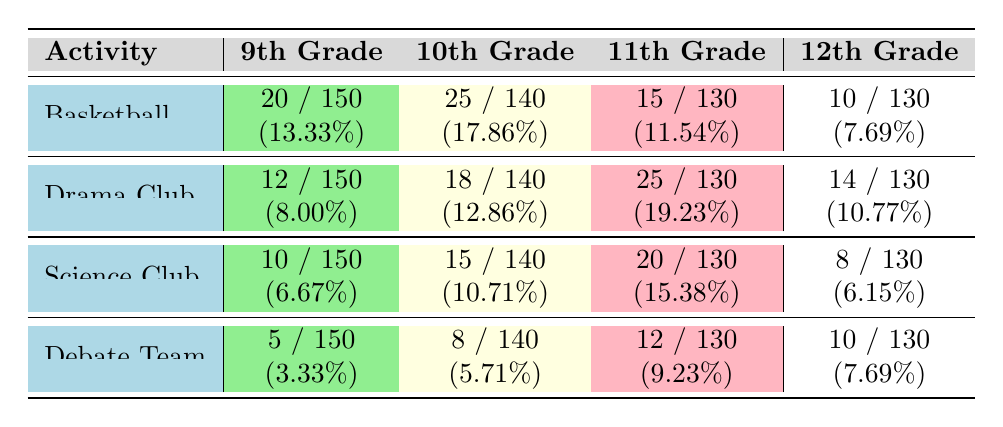What is the participation percentage for 10th Grade in the Basketball activity? The table shows that for the Basketball activity in 10th Grade, the participation percentage is listed as (17.86%).
Answer: 17.86% How many students in 11th Grade participated in the Drama Club? From the table, under the Drama Club, the entry for 11th Grade states 25 participants.
Answer: 25 Which extracurricular activity had the highest participation percentage for 12th Grade? To find this, we compare the participation percentages for each activity in 12th Grade: Basketball (7.69%), Drama Club (10.77%), Science Club (6.15%), and Debate Team (7.69%). The highest is Drama Club with 10.77%.
Answer: Drama Club What is the total number of participants in the Science Club across all grade levels? We sum the participants across all grades: 10 (9th) + 15 (10th) + 20 (11th) + 8 (12th) = 53. The total is therefore 53 participants.
Answer: 53 Is it true that the percentage of Debate Team participants decreases from 9th to 12th Grade? To determine this, we check the percentages in the table: 9th Grade is 3.33%, 10th Grade is 5.71%, 11th Grade is 9.23%, and 12th Grade is 7.69%. The percentages increase from 9th to 11th, then decrease from 11th to 12th, so the statement is only partially true.
Answer: No In which grade level did the Science Club have the highest percentage participation? Looking at the Science Club percentages: 9th Grade (6.67%), 10th Grade (10.71%), 11th Grade (15.38%), and 12th Grade (6.15%). The highest percentage is 15.38% in 11th Grade.
Answer: 11th Grade What is the difference in the number of participants between Basketball and Drama Club in 9th Grade? Basketball has 20 participants and Drama Club has 12 participants in 9th Grade. The difference is calculated as 20 - 12 = 8.
Answer: 8 Is the participation percentage in the Debate Team higher for 11th Grade than for 12th Grade? The percentages are 9.23% for 11th Grade and 7.69% for 12th Grade. Since 9.23% is greater than 7.69%, the statement is true.
Answer: Yes Which extracurricular activity has the lowest overall participation in the 10th Grade? The number of participants and their percentages for the 10th Grade shows Basketball (25 participants, 17.86%), Drama Club (18 participants, 12.86%), Science Club (15 participants, 10.71%), and Debate Team (8 participants, 5.71%). The Debate Team has the lowest participation with 8 participants.
Answer: Debate Team 